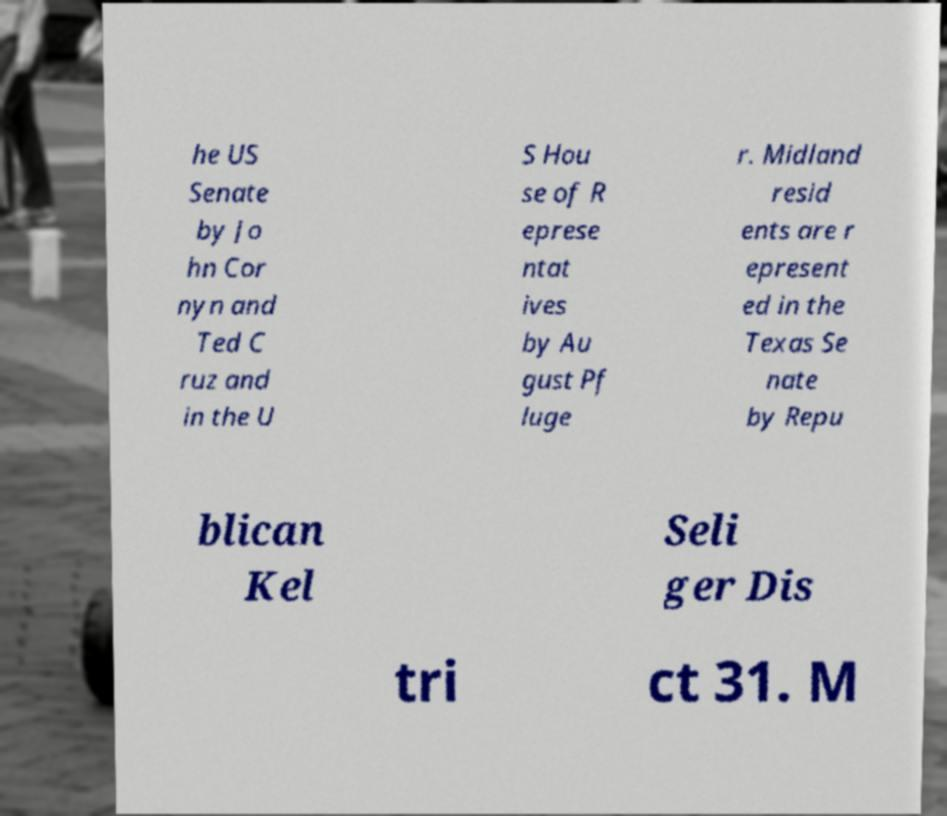There's text embedded in this image that I need extracted. Can you transcribe it verbatim? he US Senate by Jo hn Cor nyn and Ted C ruz and in the U S Hou se of R eprese ntat ives by Au gust Pf luge r. Midland resid ents are r epresent ed in the Texas Se nate by Repu blican Kel Seli ger Dis tri ct 31. M 